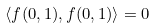Convert formula to latex. <formula><loc_0><loc_0><loc_500><loc_500>\langle f ( 0 , 1 ) , f ( 0 , 1 ) \rangle = 0</formula> 